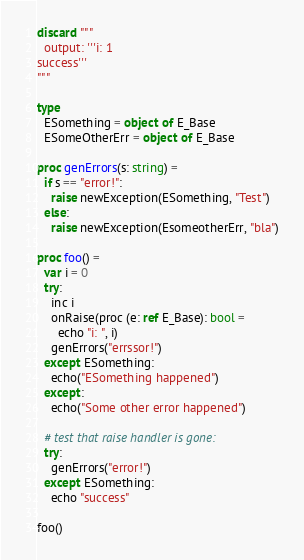Convert code to text. <code><loc_0><loc_0><loc_500><loc_500><_Nim_>discard """
  output: '''i: 1
success'''
"""

type
  ESomething = object of E_Base
  ESomeOtherErr = object of E_Base

proc genErrors(s: string) =
  if s == "error!":
    raise newException(ESomething, "Test")
  else:
    raise newException(EsomeotherErr, "bla")

proc foo() =
  var i = 0
  try:
    inc i
    onRaise(proc (e: ref E_Base): bool =
      echo "i: ", i)
    genErrors("errssor!")
  except ESomething:
    echo("ESomething happened")
  except:
    echo("Some other error happened")
    
  # test that raise handler is gone:
  try:
    genErrors("error!")
  except ESomething:
    echo "success"

foo()
</code> 